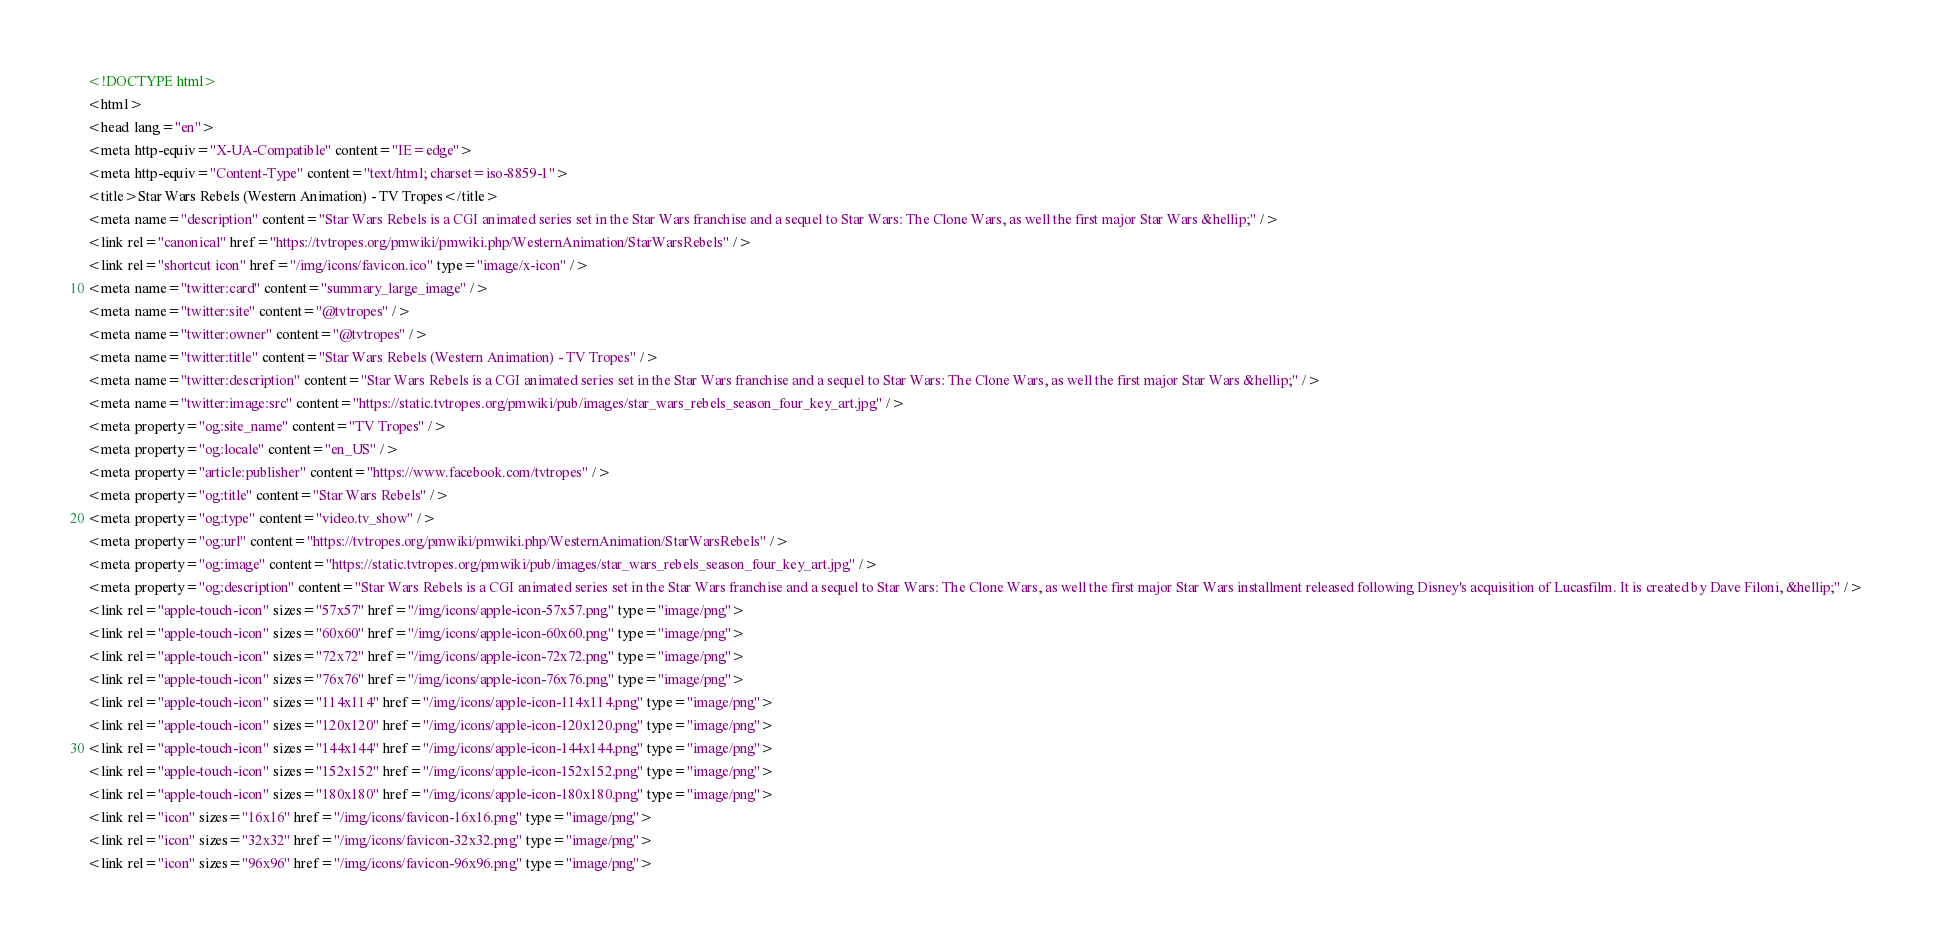<code> <loc_0><loc_0><loc_500><loc_500><_HTML_><!DOCTYPE html>
<html>
<head lang="en">
<meta http-equiv="X-UA-Compatible" content="IE=edge">
<meta http-equiv="Content-Type" content="text/html; charset=iso-8859-1">
<title>Star Wars Rebels (Western Animation) - TV Tropes</title>
<meta name="description" content="Star Wars Rebels is a CGI animated series set in the Star Wars franchise and a sequel to Star Wars: The Clone Wars, as well the first major Star Wars &hellip;" />
<link rel="canonical" href="https://tvtropes.org/pmwiki/pmwiki.php/WesternAnimation/StarWarsRebels" />
<link rel="shortcut icon" href="/img/icons/favicon.ico" type="image/x-icon" />
<meta name="twitter:card" content="summary_large_image" />
<meta name="twitter:site" content="@tvtropes" />
<meta name="twitter:owner" content="@tvtropes" />
<meta name="twitter:title" content="Star Wars Rebels (Western Animation) - TV Tropes" />
<meta name="twitter:description" content="Star Wars Rebels is a CGI animated series set in the Star Wars franchise and a sequel to Star Wars: The Clone Wars, as well the first major Star Wars &hellip;" />
<meta name="twitter:image:src" content="https://static.tvtropes.org/pmwiki/pub/images/star_wars_rebels_season_four_key_art.jpg" />
<meta property="og:site_name" content="TV Tropes" />
<meta property="og:locale" content="en_US" />
<meta property="article:publisher" content="https://www.facebook.com/tvtropes" />
<meta property="og:title" content="Star Wars Rebels" />
<meta property="og:type" content="video.tv_show" />
<meta property="og:url" content="https://tvtropes.org/pmwiki/pmwiki.php/WesternAnimation/StarWarsRebels" />
<meta property="og:image" content="https://static.tvtropes.org/pmwiki/pub/images/star_wars_rebels_season_four_key_art.jpg" />
<meta property="og:description" content="Star Wars Rebels is a CGI animated series set in the Star Wars franchise and a sequel to Star Wars: The Clone Wars, as well the first major Star Wars installment released following Disney's acquisition of Lucasfilm. It is created by Dave Filoni, &hellip;" />
<link rel="apple-touch-icon" sizes="57x57" href="/img/icons/apple-icon-57x57.png" type="image/png">
<link rel="apple-touch-icon" sizes="60x60" href="/img/icons/apple-icon-60x60.png" type="image/png">
<link rel="apple-touch-icon" sizes="72x72" href="/img/icons/apple-icon-72x72.png" type="image/png">
<link rel="apple-touch-icon" sizes="76x76" href="/img/icons/apple-icon-76x76.png" type="image/png">
<link rel="apple-touch-icon" sizes="114x114" href="/img/icons/apple-icon-114x114.png" type="image/png">
<link rel="apple-touch-icon" sizes="120x120" href="/img/icons/apple-icon-120x120.png" type="image/png">
<link rel="apple-touch-icon" sizes="144x144" href="/img/icons/apple-icon-144x144.png" type="image/png">
<link rel="apple-touch-icon" sizes="152x152" href="/img/icons/apple-icon-152x152.png" type="image/png">
<link rel="apple-touch-icon" sizes="180x180" href="/img/icons/apple-icon-180x180.png" type="image/png">
<link rel="icon" sizes="16x16" href="/img/icons/favicon-16x16.png" type="image/png">
<link rel="icon" sizes="32x32" href="/img/icons/favicon-32x32.png" type="image/png">
<link rel="icon" sizes="96x96" href="/img/icons/favicon-96x96.png" type="image/png"></code> 